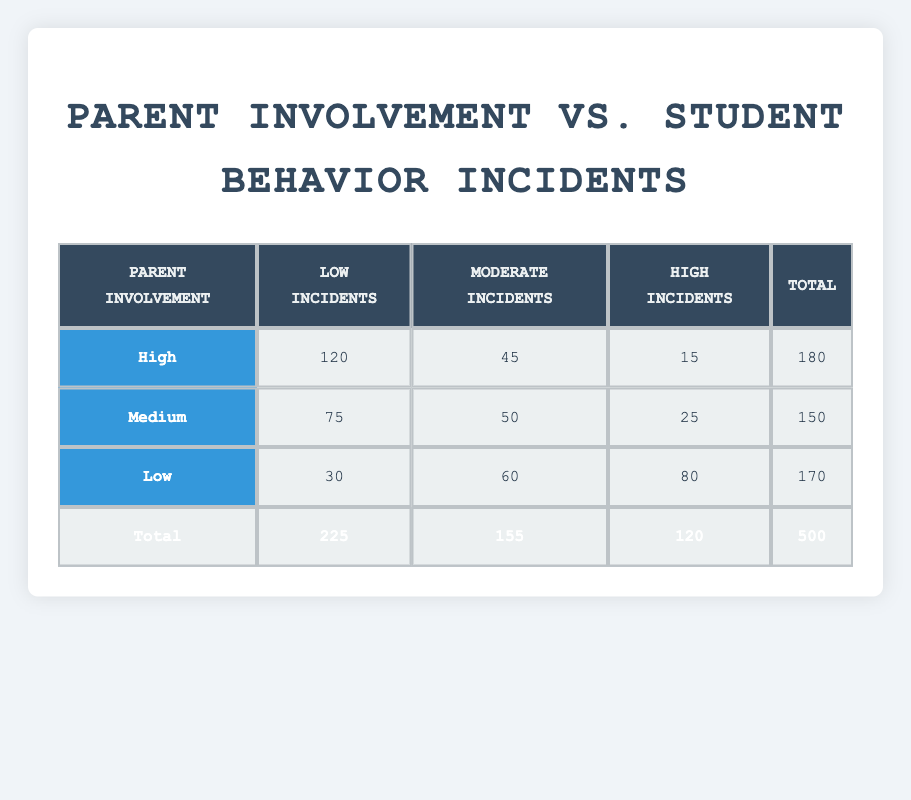What is the total number of students with low behavior incidents and high parent involvement? Referring to the table, the count for high parent involvement with low behavior incidents is 120.
Answer: 120 How many students have moderate behavior incidents and low parent involvement? The count for low parent involvement with moderate behavior incidents is 60, as per the table.
Answer: 60 Is there a group with high behavior incidents where parent involvement is at a high level? The table shows that there are 15 students with high behavior incidents and high parent involvement, confirming the existence of this group.
Answer: Yes What is the total number of students with medium parent involvement? To find the total, add the counts for medium parent involvement in all behavior incident categories: 75 (low) + 50 (moderate) + 25 (high) = 150.
Answer: 150 Which level of parent involvement has the highest count of behavior incidents labeled as high? By examining the table, we see that the low parent involvement group has the highest count, with 80 students having high behavior incidents.
Answer: Low What is the average number of students across all behavior incident categories for high parent involvement? The average can be calculated by summing the counts for high parent involvement: (120 + 45 + 15) = 180. Divide by 3 categories gives 180/3 = 60.
Answer: 60 How many more students are there with low behavior incidents compared to high behavior incidents overall? The total for low behavior incidents is 225 (120 + 75 + 30) and for high behavior incidents, it's 120 (15 + 25 + 80). Taking the difference: 225 - 120 = 105.
Answer: 105 Is the number of students with moderate incidents and medium parent involvement greater than those with low incidents and low parent involvement? Medium parent involvement has 50 students for moderate incidents while low parent involvement has 30 for low incidents. Since 50 > 30, the statement is true.
Answer: Yes What percentage of students with high parent involvement have low behavior incidents? There are 120 students with low incidents and the total for high parent involvement is 180. The percentage is (120/180)*100 = 66.67%.
Answer: 66.67% 